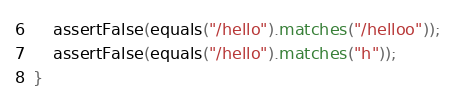<code> <loc_0><loc_0><loc_500><loc_500><_Ceylon_>    assertFalse(equals("/hello").matches("/helloo"));
    assertFalse(equals("/hello").matches("h"));
}
</code> 